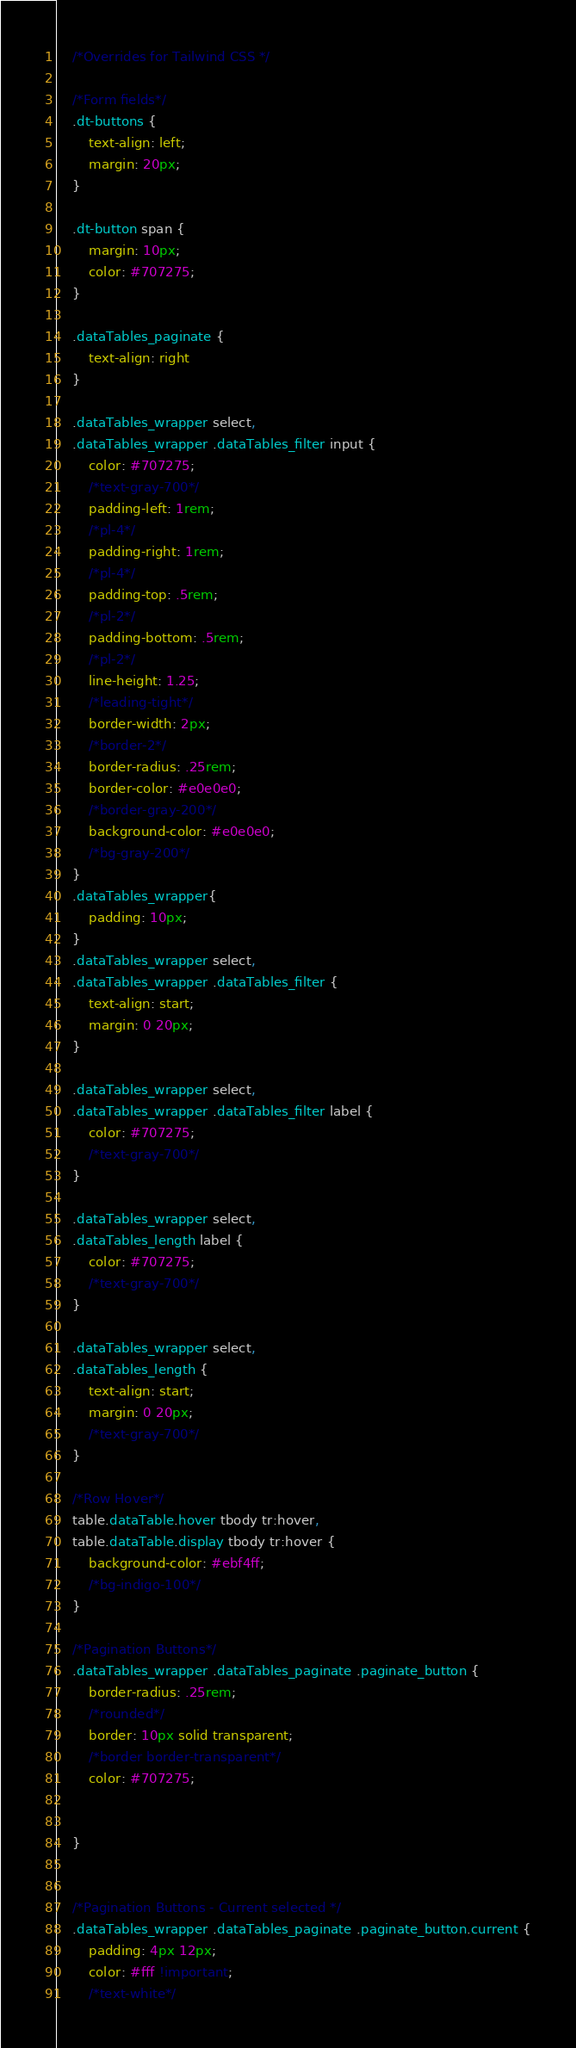Convert code to text. <code><loc_0><loc_0><loc_500><loc_500><_CSS_>    /*Overrides for Tailwind CSS */

    /*Form fields*/
    .dt-buttons {
        text-align: left;
        margin: 20px;
    }

    .dt-button span {
        margin: 10px;
        color: #707275;
    }

    .dataTables_paginate {
        text-align: right
    }

    .dataTables_wrapper select,
    .dataTables_wrapper .dataTables_filter input {
        color: #707275;
        /*text-gray-700*/
        padding-left: 1rem;
        /*pl-4*/
        padding-right: 1rem;
        /*pl-4*/
        padding-top: .5rem;
        /*pl-2*/
        padding-bottom: .5rem;
        /*pl-2*/
        line-height: 1.25;
        /*leading-tight*/
        border-width: 2px;
        /*border-2*/
        border-radius: .25rem;
        border-color: #e0e0e0;
        /*border-gray-200*/
        background-color: #e0e0e0;
        /*bg-gray-200*/
    }
    .dataTables_wrapper{
        padding: 10px;
    }
    .dataTables_wrapper select,
    .dataTables_wrapper .dataTables_filter {
        text-align: start;
        margin: 0 20px;
    }

    .dataTables_wrapper select,
    .dataTables_wrapper .dataTables_filter label {
        color: #707275;
        /*text-gray-700*/
    }

    .dataTables_wrapper select,
    .dataTables_length label {
        color: #707275;
        /*text-gray-700*/
    }

    .dataTables_wrapper select,
    .dataTables_length {
        text-align: start;
        margin: 0 20px;
        /*text-gray-700*/
    }

    /*Row Hover*/
    table.dataTable.hover tbody tr:hover,
    table.dataTable.display tbody tr:hover {
        background-color: #ebf4ff;
        /*bg-indigo-100*/
    }

    /*Pagination Buttons*/
    .dataTables_wrapper .dataTables_paginate .paginate_button {
        border-radius: .25rem;
        /*rounded*/
        border: 10px solid transparent;
        /*border border-transparent*/
        color: #707275;


    }


    /*Pagination Buttons - Current selected */
    .dataTables_wrapper .dataTables_paginate .paginate_button.current {
        padding: 4px 12px;
        color: #fff !important;
        /*text-white*/</code> 